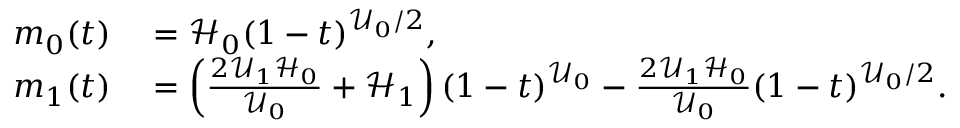Convert formula to latex. <formula><loc_0><loc_0><loc_500><loc_500>\begin{array} { r l } { m _ { 0 } ( t ) } & = \mathcal { H } _ { 0 } ( 1 - t ) ^ { \mathcal { U } _ { 0 } / 2 } , } \\ { m _ { 1 } ( t ) } & = \left ( \frac { 2 \mathcal { U } _ { 1 } \mathcal { H } _ { 0 } } { \mathcal { U } _ { 0 } } + \mathcal { H } _ { 1 } \right ) ( 1 - t ) ^ { \mathcal { U } _ { 0 } } - \frac { 2 \mathcal { U } _ { 1 } \mathcal { H } _ { 0 } } { \mathcal { U } _ { 0 } } ( 1 - t ) ^ { \mathcal { U } _ { 0 } / 2 } . } \end{array}</formula> 